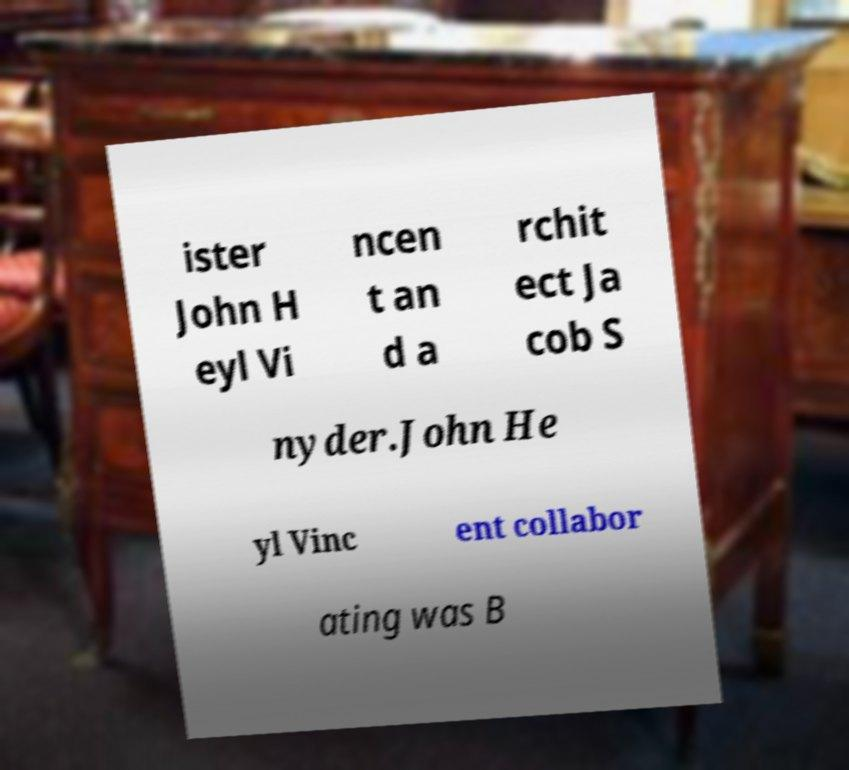Can you accurately transcribe the text from the provided image for me? ister John H eyl Vi ncen t an d a rchit ect Ja cob S nyder.John He yl Vinc ent collabor ating was B 